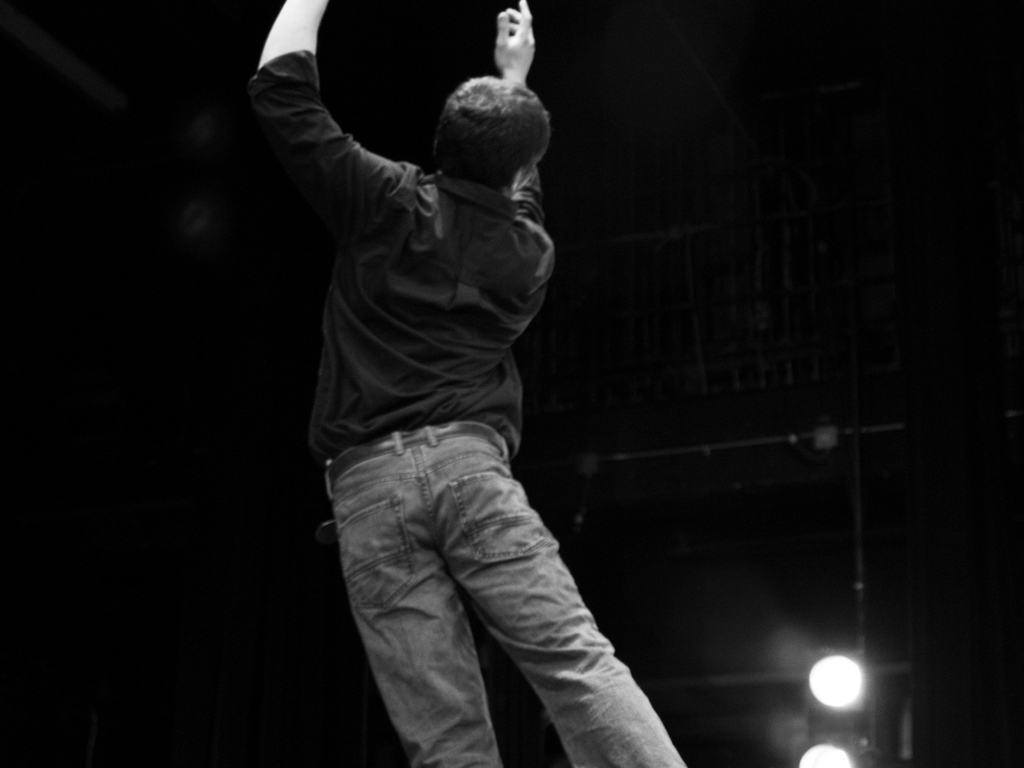Can you infer what the person in the image might be doing? Based on the individual's stance and uplifted arms, it seems they are engaged in an expressive activity, possibly dancing, acting or partaking in a rehearsal. The lack of sharp focus adds to the dynamic, motion-filled interpretation of their action. Is this image part of a larger series, and can you tell if it's spontaneous or staged? Without additional context, it's challenging to conclude whether this image is part of a series. However, its composition suggests it might be a candid shot taken during a live performance, capturing a spontaneous moment rather than a prearranged pose. 